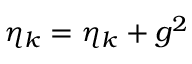<formula> <loc_0><loc_0><loc_500><loc_500>\eta _ { k } = \eta _ { k } + g ^ { 2 }</formula> 